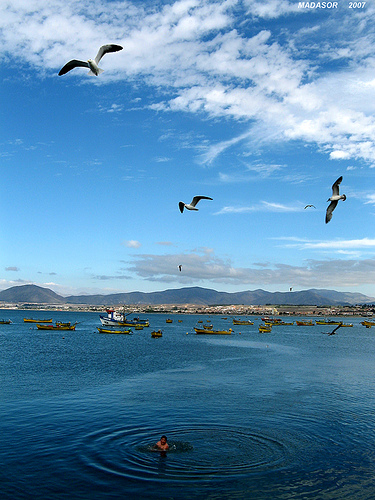Can you describe the weather conditions in the image? The sky is mostly clear with a few scattered clouds suggesting fair weather. The water is calm, indicating a gentle breeze, if any. Overall, the conditions appear to be ideal for a serene day by the sea or out on a boat. 